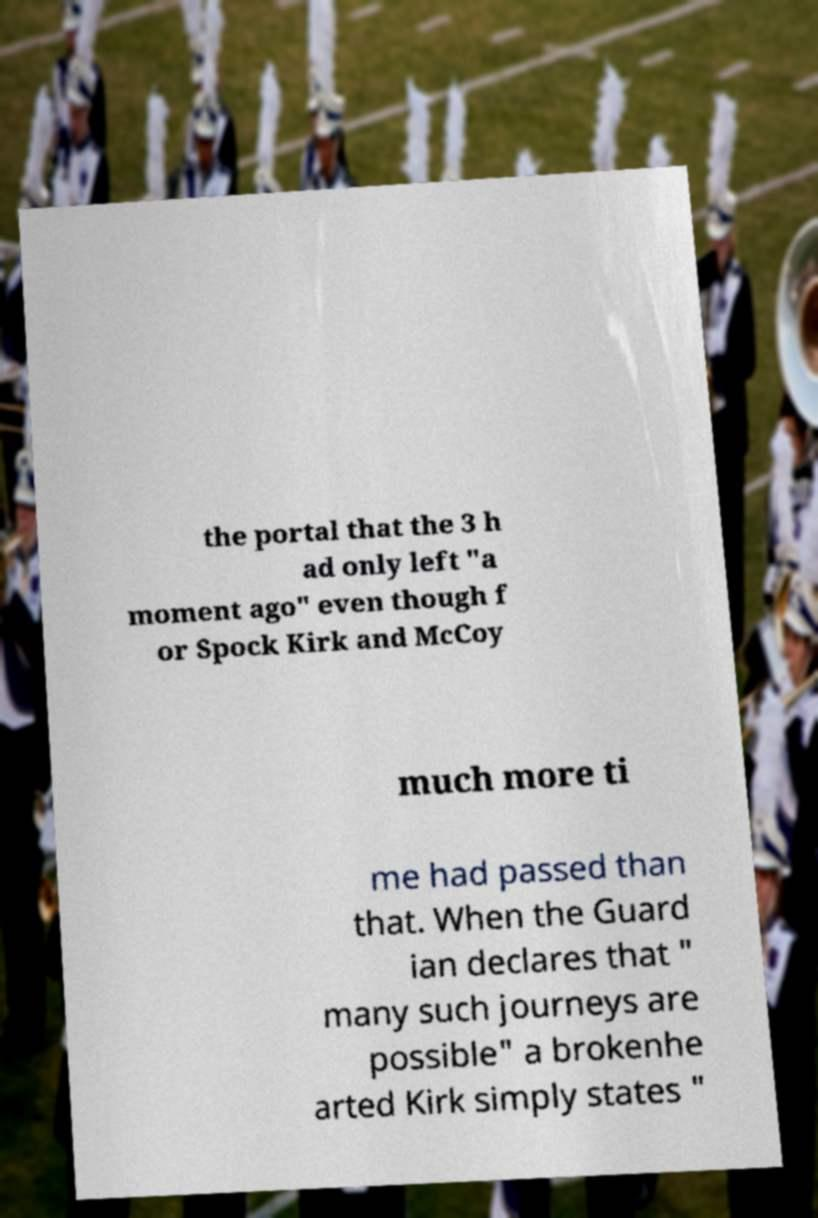Please identify and transcribe the text found in this image. the portal that the 3 h ad only left "a moment ago" even though f or Spock Kirk and McCoy much more ti me had passed than that. When the Guard ian declares that " many such journeys are possible" a brokenhe arted Kirk simply states " 